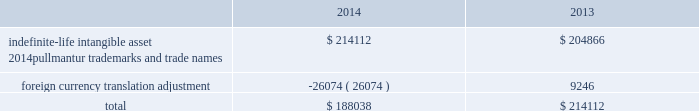Royal caribbean cruises ltd .
79 notes to the consolidated financial statements in 2012 , we determined the implied fair value of good- will for the pullmantur reporting unit was $ 145.5 mil- lion and recognized an impairment charge of $ 319.2 million based on a probability-weighted discounted cash flow model further discussed below .
This impair- ment charge was recognized in earnings during the fourth quarter of 2012 and is reported within impair- ment of pullmantur related assets within our consoli- dated statements of comprehensive income ( loss ) .
During the fourth quarter of 2014 , we performed a qualitative assessment of whether it was more-likely- than-not that our royal caribbean international reporting unit 2019s fair value was less than its carrying amount before applying the two-step goodwill impair- ment test .
The qualitative analysis included assessing the impact of certain factors such as general economic conditions , limitations on accessing capital , changes in forecasted operating results , changes in fuel prices and fluctuations in foreign exchange rates .
Based on our qualitative assessment , we concluded that it was more-likely-than-not that the estimated fair value of the royal caribbean international reporting unit exceeded its carrying value and thus , we did not pro- ceed to the two-step goodwill impairment test .
No indicators of impairment exist primarily because the reporting unit 2019s fair value has consistently exceeded its carrying value by a significant margin , its financial performance has been solid in the face of mixed economic environments and forecasts of operating results generated by the reporting unit appear suffi- cient to support its carrying value .
We also performed our annual impairment review of goodwill for pullmantur 2019s reporting unit during the fourth quarter of 2014 .
We did not perform a quali- tative assessment but instead proceeded directly to the two-step goodwill impairment test .
We estimated the fair value of the pullmantur reporting unit using a probability-weighted discounted cash flow model .
The principal assumptions used in the discounted cash flow model are projected operating results , weighted- average cost of capital , and terminal value .
Signifi- cantly impacting these assumptions are the transfer of vessels from our other cruise brands to pullmantur .
The discounted cash flow model used our 2015 pro- jected operating results as a base .
To that base , we added future years 2019 cash flows assuming multiple rev- enue and expense scenarios that reflect the impact of different global economic environments beyond 2015 on pullmantur 2019s reporting unit .
We assigned a probability to each revenue and expense scenario .
We discounted the projected cash flows using rates specific to pullmantur 2019s reporting unit based on its weighted-average cost of capital .
Based on the probability-weighted discounted cash flows , we deter- mined the fair value of the pullmantur reporting unit exceeded its carrying value by approximately 52% ( 52 % ) resulting in no impairment to pullmantur 2019s goodwill .
Pullmantur is a brand targeted primarily at the spanish , portuguese and latin american markets , with an increasing focus on latin america .
The persistent economic instability in these markets has created sig- nificant uncertainties in forecasting operating results and future cash flows used in our impairment analyses .
We continue to monitor economic events in these markets for their potential impact on pullmantur 2019s business and valuation .
Further , the estimation of fair value utilizing discounted expected future cash flows includes numerous uncertainties which require our significant judgment when making assumptions of expected revenues , operating costs , marketing , sell- ing and administrative expenses , interest rates , ship additions and retirements as well as assumptions regarding the cruise vacation industry 2019s competitive environment and general economic and business conditions , among other factors .
If there are changes to the projected future cash flows used in the impairment analyses , especially in net yields or if certain transfers of vessels from our other cruise brands to the pullmantur fleet do not take place , it is possible that an impairment charge of pullmantur 2019s reporting unit 2019s goodwill may be required .
Of these factors , the planned transfers of vessels to the pullmantur fleet is most significant to the projected future cash flows .
If the transfers do not occur , we will likely fail step one of the impairment test .
Note 4 .
Intangible assets intangible assets are reported in other assets in our consolidated balance sheets and consist of the follow- ing ( in thousands ) : .
During the fourth quarter of 2014 , 2013 and 2012 , we performed the annual impairment review of pullmantur 2019s trademarks and trade names using a discounted cash flow model and the relief-from-royalty method to compare the fair value of these indefinite-lived intan- gible assets to its carrying value .
The royalty rate used is based on comparable royalty agreements in the tourism and hospitality industry .
We used a dis- count rate comparable to the rate used in valuing the pullmantur reporting unit in our goodwill impairment test .
Based on the results of our testing , we did not .
In 2012 what was the percentage recognized impairment charge of? 
Computations: (319.2 / (145.5 + 319.2))
Answer: 0.68689. 